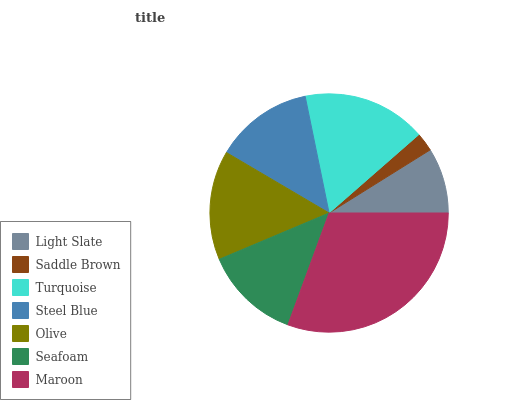Is Saddle Brown the minimum?
Answer yes or no. Yes. Is Maroon the maximum?
Answer yes or no. Yes. Is Turquoise the minimum?
Answer yes or no. No. Is Turquoise the maximum?
Answer yes or no. No. Is Turquoise greater than Saddle Brown?
Answer yes or no. Yes. Is Saddle Brown less than Turquoise?
Answer yes or no. Yes. Is Saddle Brown greater than Turquoise?
Answer yes or no. No. Is Turquoise less than Saddle Brown?
Answer yes or no. No. Is Steel Blue the high median?
Answer yes or no. Yes. Is Steel Blue the low median?
Answer yes or no. Yes. Is Turquoise the high median?
Answer yes or no. No. Is Turquoise the low median?
Answer yes or no. No. 